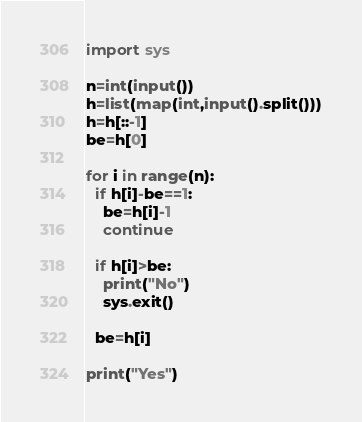<code> <loc_0><loc_0><loc_500><loc_500><_Python_>import sys

n=int(input())
h=list(map(int,input().split()))
h=h[::-1]
be=h[0]

for i in range(n):
  if h[i]-be==1:
    be=h[i]-1
    continue
    
  if h[i]>be:
    print("No")
    sys.exit()
  
  be=h[i]
  
print("Yes")</code> 